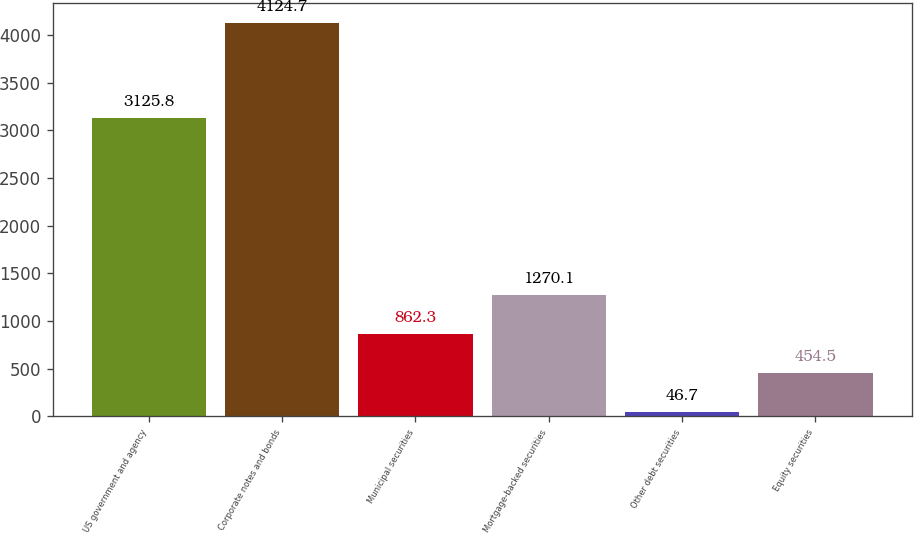Convert chart to OTSL. <chart><loc_0><loc_0><loc_500><loc_500><bar_chart><fcel>US government and agency<fcel>Corporate notes and bonds<fcel>Municipal securities<fcel>Mortgage-backed securities<fcel>Other debt securities<fcel>Equity securities<nl><fcel>3125.8<fcel>4124.7<fcel>862.3<fcel>1270.1<fcel>46.7<fcel>454.5<nl></chart> 